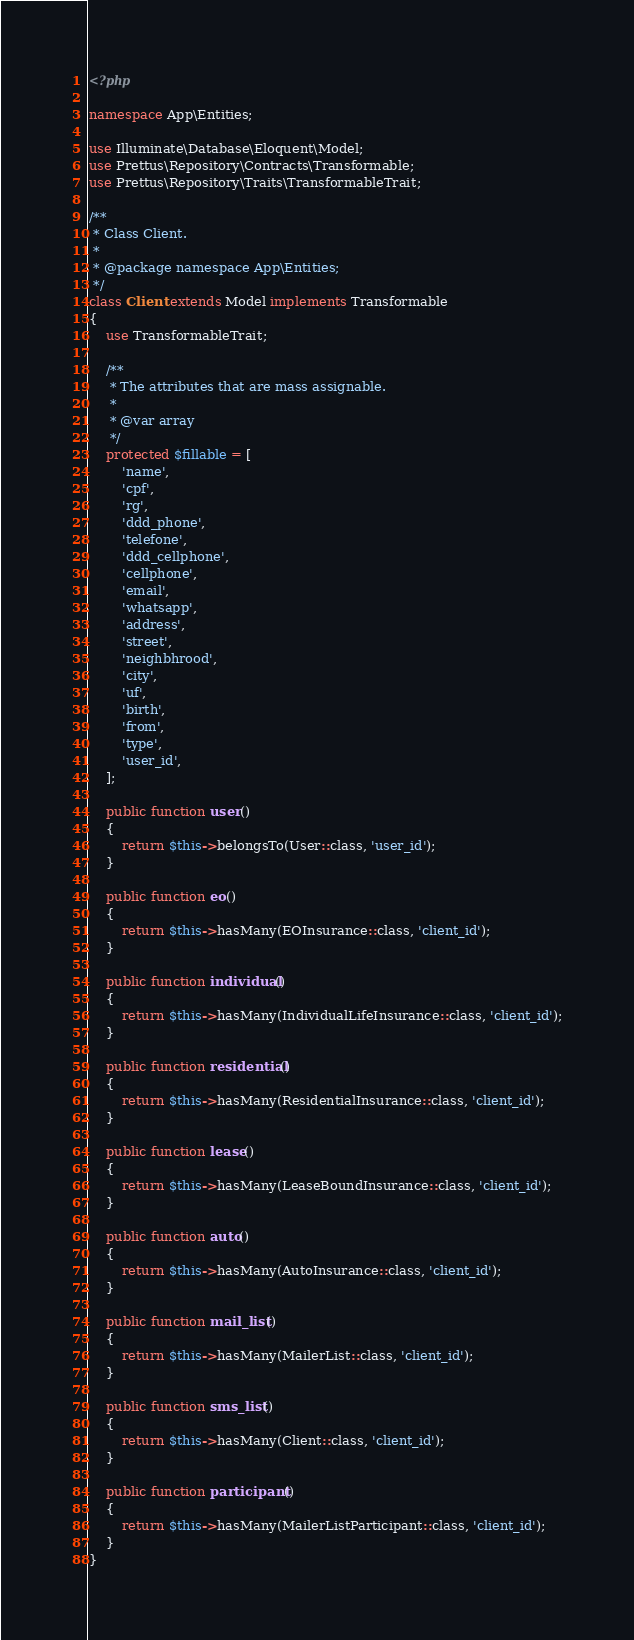Convert code to text. <code><loc_0><loc_0><loc_500><loc_500><_PHP_><?php

namespace App\Entities;

use Illuminate\Database\Eloquent\Model;
use Prettus\Repository\Contracts\Transformable;
use Prettus\Repository\Traits\TransformableTrait;

/**
 * Class Client.
 *
 * @package namespace App\Entities;
 */
class Client extends Model implements Transformable
{
    use TransformableTrait;

    /**
     * The attributes that are mass assignable.
     *
     * @var array
     */
    protected $fillable = [
        'name',
        'cpf',
		'rg',
		'ddd_phone',
		'telefone',
		'ddd_cellphone',
		'cellphone',
		'email',
		'whatsapp',
		'address',
		'street',
		'neighbhrood',
		'city',
		'uf',
		'birth',
		'from',
        'type',
		'user_id',
	];
	
	public function user() 
	{
		return $this->belongsTo(User::class, 'user_id');
	}

    public function eo()
    {
        return $this->hasMany(EOInsurance::class, 'client_id');
	}

    public function individual()
    {
        return $this->hasMany(IndividualLifeInsurance::class, 'client_id');
	}

    public function residential()
    {
        return $this->hasMany(ResidentialInsurance::class, 'client_id');
    }

    public function lease()
    {
        return $this->hasMany(LeaseBoundInsurance::class, 'client_id');
    }

    public function auto()
    {
        return $this->hasMany(AutoInsurance::class, 'client_id');
    }

    public function mail_list()
    {
        return $this->hasMany(MailerList::class, 'client_id');
    }

    public function sms_list()
    {
        return $this->hasMany(Client::class, 'client_id');
    }

    public function participant()
    {
        return $this->hasMany(MailerListParticipant::class, 'client_id');
    }
}
</code> 